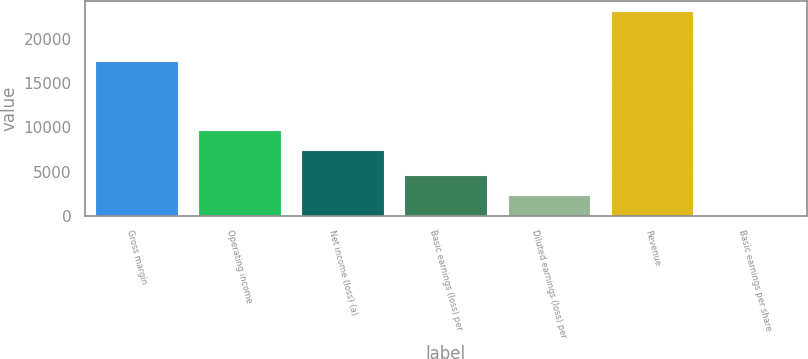Convert chart. <chart><loc_0><loc_0><loc_500><loc_500><bar_chart><fcel>Gross margin<fcel>Operating income<fcel>Net income (loss) (a)<fcel>Basic earnings (loss) per<fcel>Diluted earnings (loss) per<fcel>Revenue<fcel>Basic earnings per share<nl><fcel>17550<fcel>9745.13<fcel>7424<fcel>4642.97<fcel>2321.84<fcel>23212<fcel>0.71<nl></chart> 